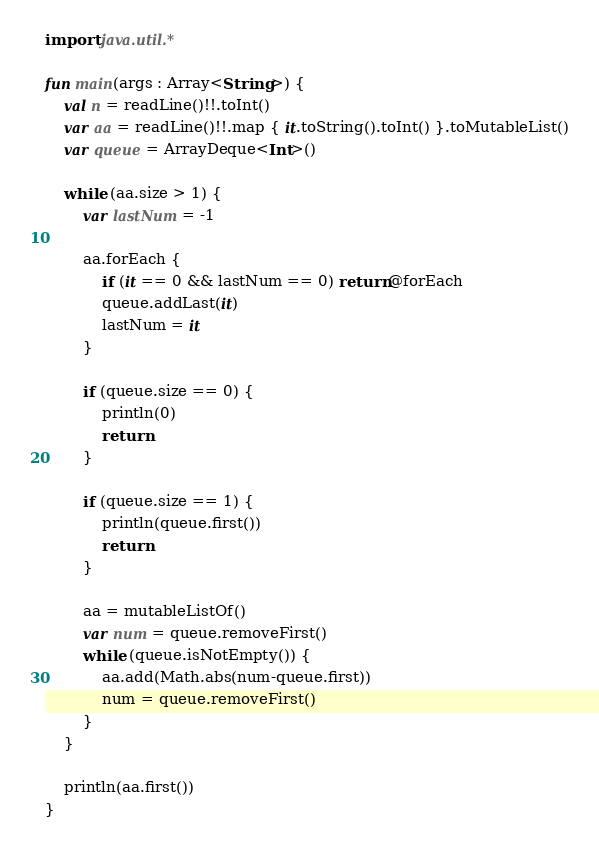Convert code to text. <code><loc_0><loc_0><loc_500><loc_500><_Kotlin_>import java.util.*

fun main(args : Array<String>) {
    val n = readLine()!!.toInt()
    var aa = readLine()!!.map { it.toString().toInt() }.toMutableList()
    var queue = ArrayDeque<Int>()

    while (aa.size > 1) {
        var lastNum = -1

        aa.forEach {
            if (it == 0 && lastNum == 0) return@forEach
            queue.addLast(it)
            lastNum = it
        }

        if (queue.size == 0) {
            println(0)
            return
        }

        if (queue.size == 1) {
            println(queue.first())
            return
        }

        aa = mutableListOf()
        var num = queue.removeFirst()
        while (queue.isNotEmpty()) {
            aa.add(Math.abs(num-queue.first))
            num = queue.removeFirst()
        }
    }

    println(aa.first())
}</code> 